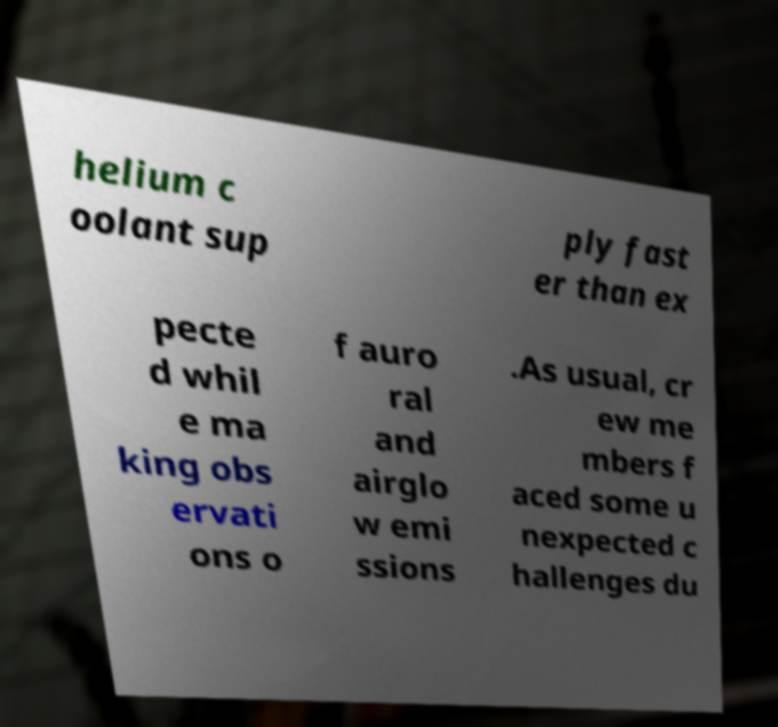There's text embedded in this image that I need extracted. Can you transcribe it verbatim? helium c oolant sup ply fast er than ex pecte d whil e ma king obs ervati ons o f auro ral and airglo w emi ssions .As usual, cr ew me mbers f aced some u nexpected c hallenges du 